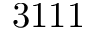<formula> <loc_0><loc_0><loc_500><loc_500>3 1 1 1</formula> 